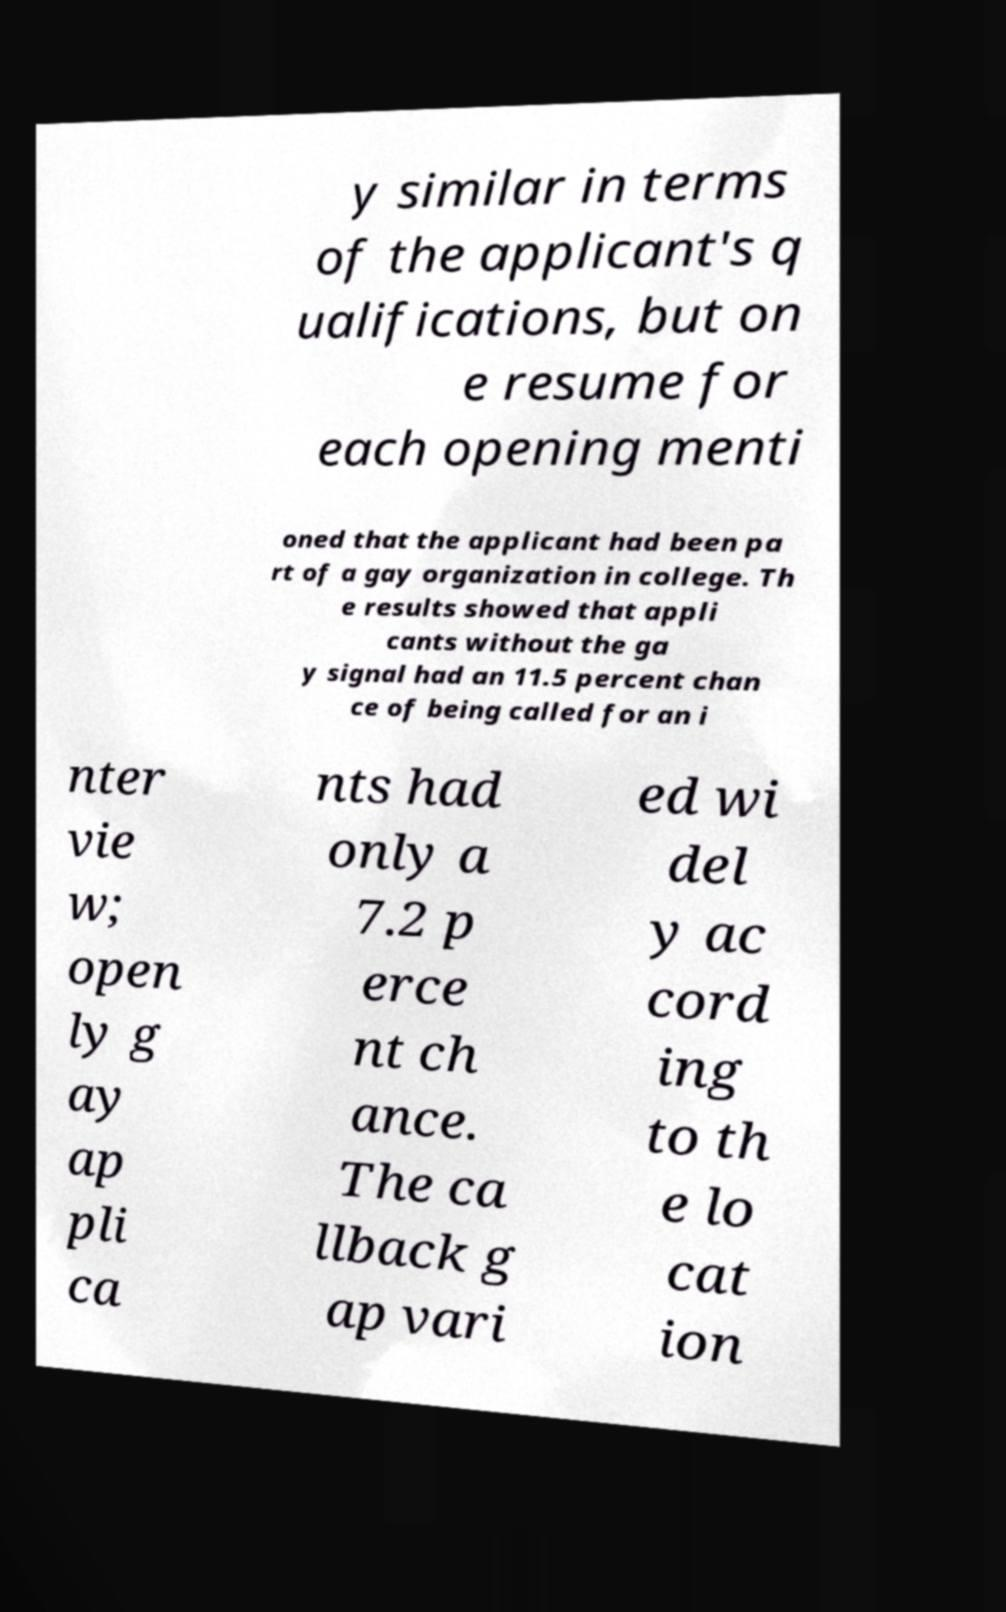Please identify and transcribe the text found in this image. y similar in terms of the applicant's q ualifications, but on e resume for each opening menti oned that the applicant had been pa rt of a gay organization in college. Th e results showed that appli cants without the ga y signal had an 11.5 percent chan ce of being called for an i nter vie w; open ly g ay ap pli ca nts had only a 7.2 p erce nt ch ance. The ca llback g ap vari ed wi del y ac cord ing to th e lo cat ion 